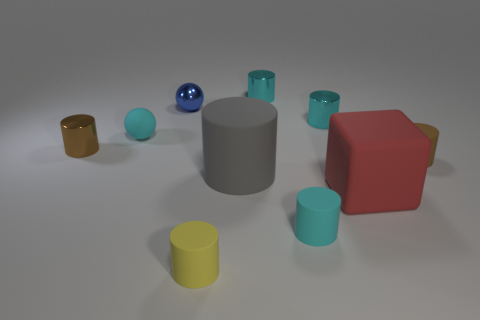What is the shape of the rubber object that is on the left side of the cyan rubber cylinder and in front of the big red cube?
Offer a terse response. Cylinder. There is a brown cylinder that is to the right of the small brown metallic object behind the gray cylinder; what is its size?
Keep it short and to the point. Small. How many other blocks have the same color as the big matte block?
Provide a succinct answer. 0. What number of other things are there of the same size as the red object?
Keep it short and to the point. 1. What size is the shiny thing that is both on the left side of the yellow cylinder and in front of the tiny blue metal object?
Provide a short and direct response. Small. How many cyan matte objects are the same shape as the gray matte object?
Offer a terse response. 1. What is the small yellow object made of?
Provide a succinct answer. Rubber. Does the large red thing have the same shape as the large gray thing?
Ensure brevity in your answer.  No. Is there a red cube made of the same material as the small blue object?
Provide a short and direct response. No. What is the color of the cylinder that is left of the big gray rubber thing and behind the yellow rubber cylinder?
Offer a terse response. Brown. 